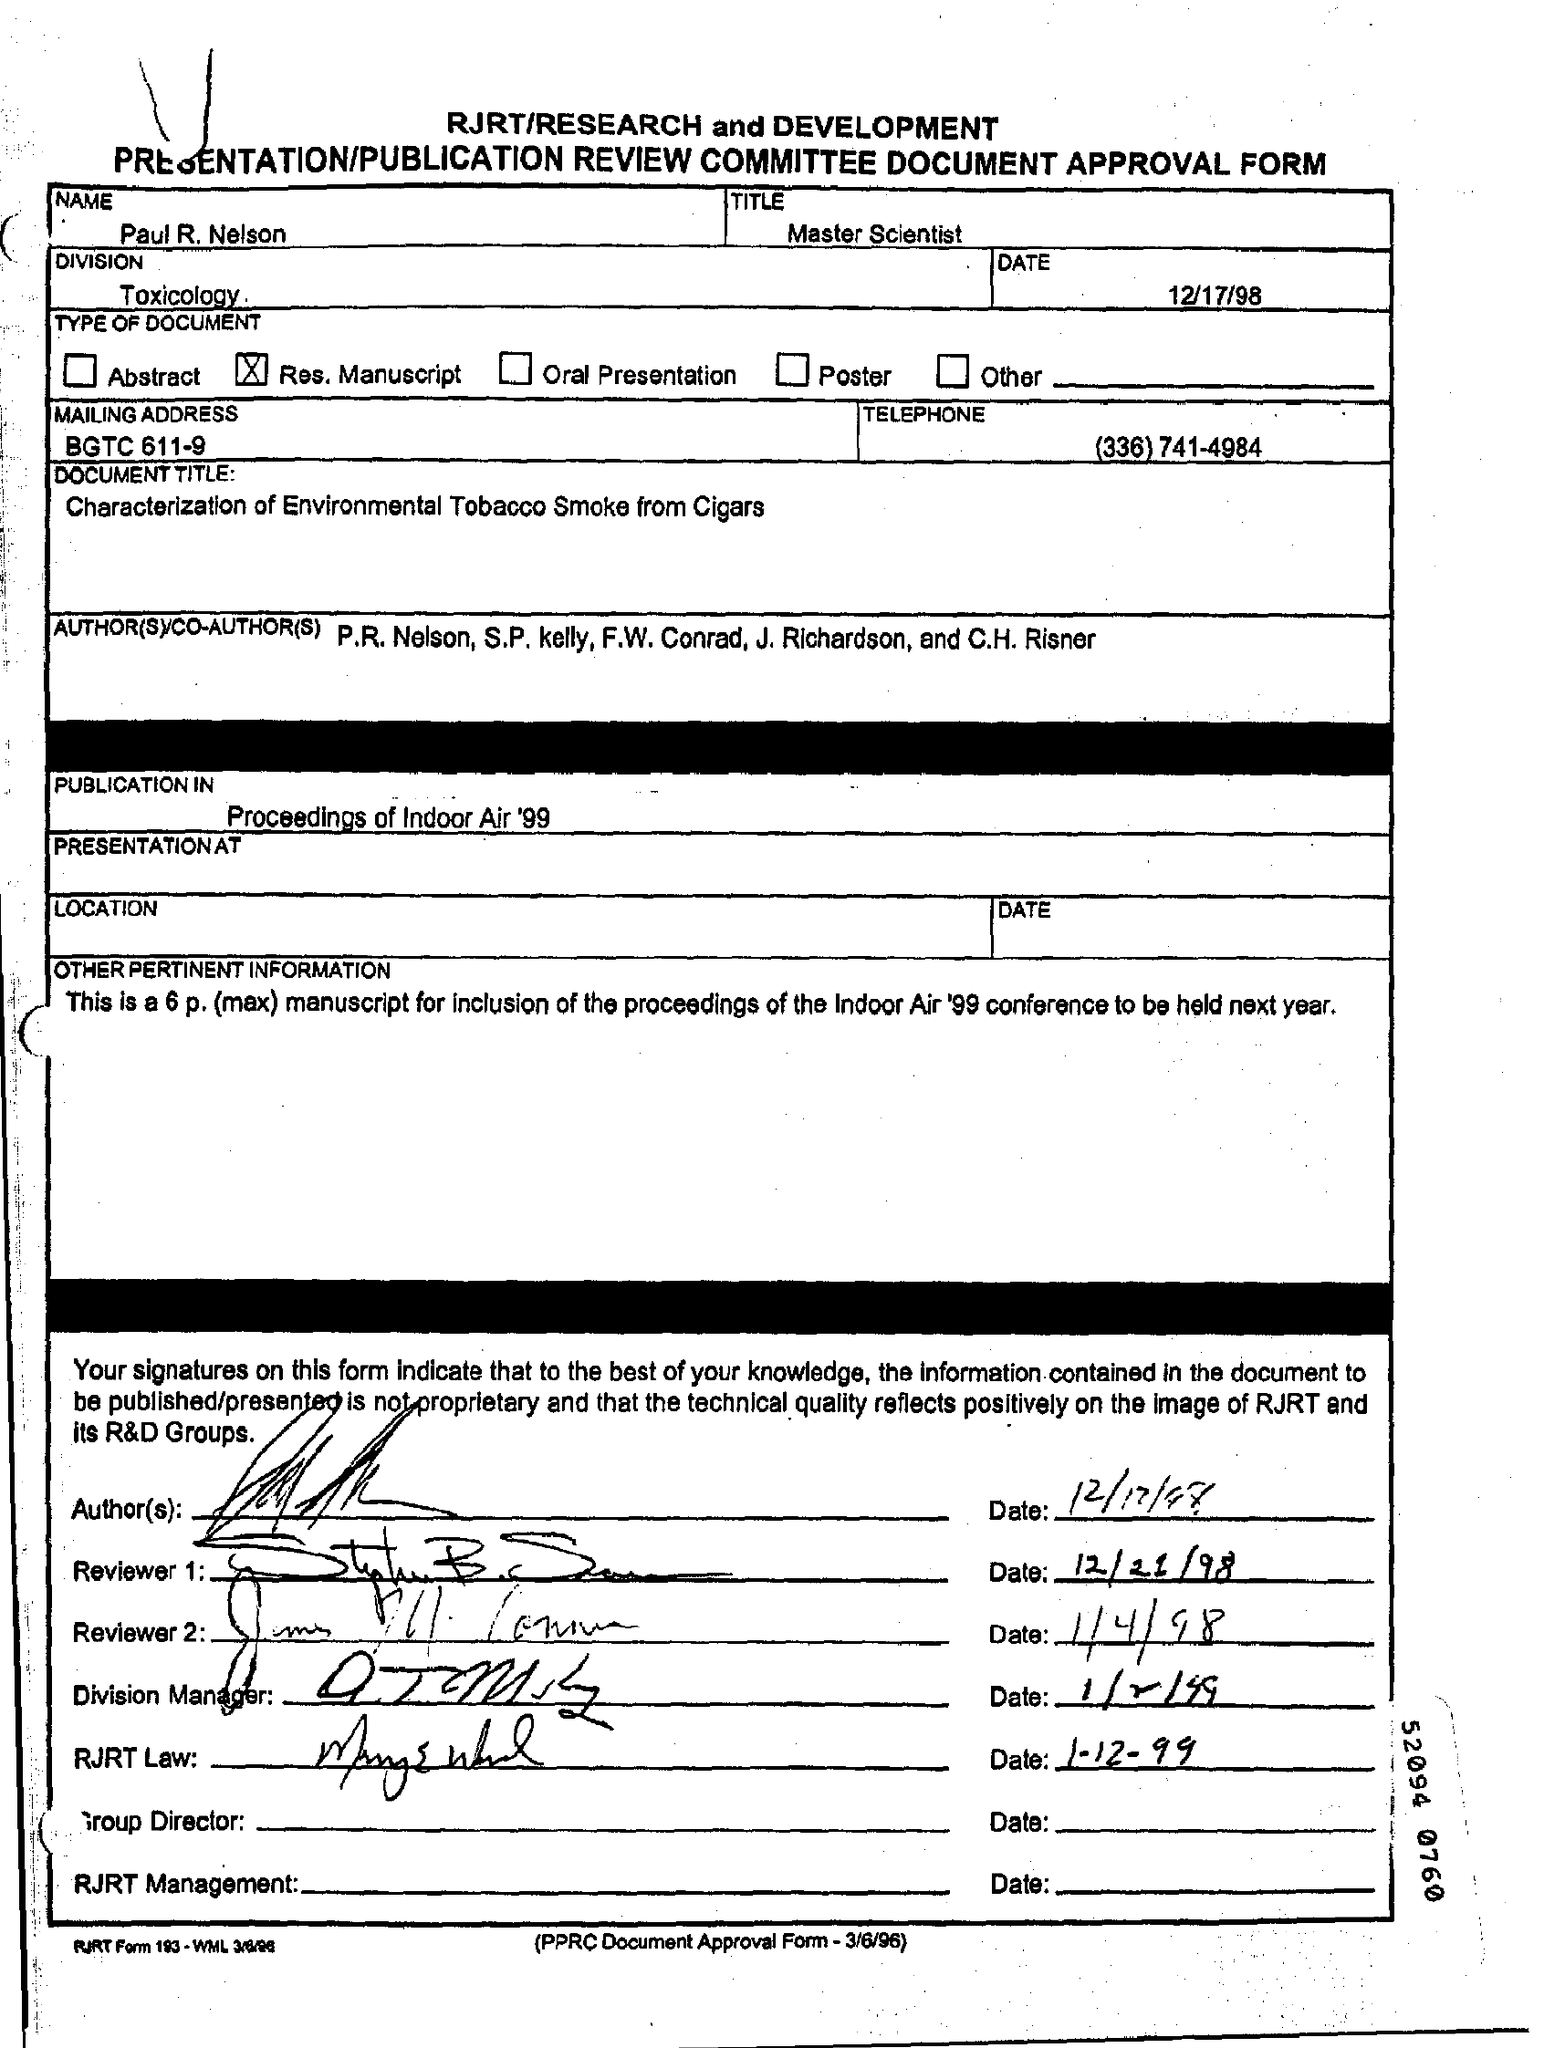Outline some significant characteristics in this image. The name given is Paul R. Nelson. The manuscript is scheduled to be published in the "Proceedings of Indoor Air '99". Paul's designation is Master Scientist. The division that is mentioned is TOXICOLOGY. The document title is 'CHARACTERIZATION OF ENVIRONMENTAL TOBACCO SMOKE FROM CIGARS..' 